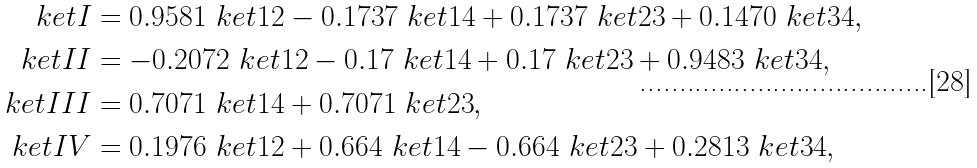Convert formula to latex. <formula><loc_0><loc_0><loc_500><loc_500>\ k e t { I } & = 0 . 9 5 8 1 \ k e t { 1 2 } - 0 . 1 7 3 7 \ k e t { 1 4 } + 0 . 1 7 3 7 \ k e t { 2 3 } + 0 . 1 4 7 0 \ k e t { 3 4 } , \\ \ k e t { I I } & = - 0 . 2 0 7 2 \ k e t { 1 2 } - 0 . 1 7 \ k e t { 1 4 } + 0 . 1 7 \ k e t { 2 3 } + 0 . 9 4 8 3 \ k e t { 3 4 } , \\ \ k e t { I I I } & = 0 . 7 0 7 1 \ k e t { 1 4 } + 0 . 7 0 7 1 \ k e t { 2 3 } , \\ \ k e t { I V } & = 0 . 1 9 7 6 \ k e t { 1 2 } + 0 . 6 6 4 \ k e t { 1 4 } - 0 . 6 6 4 \ k e t { 2 3 } + 0 . 2 8 1 3 \ k e t { 3 4 } ,</formula> 